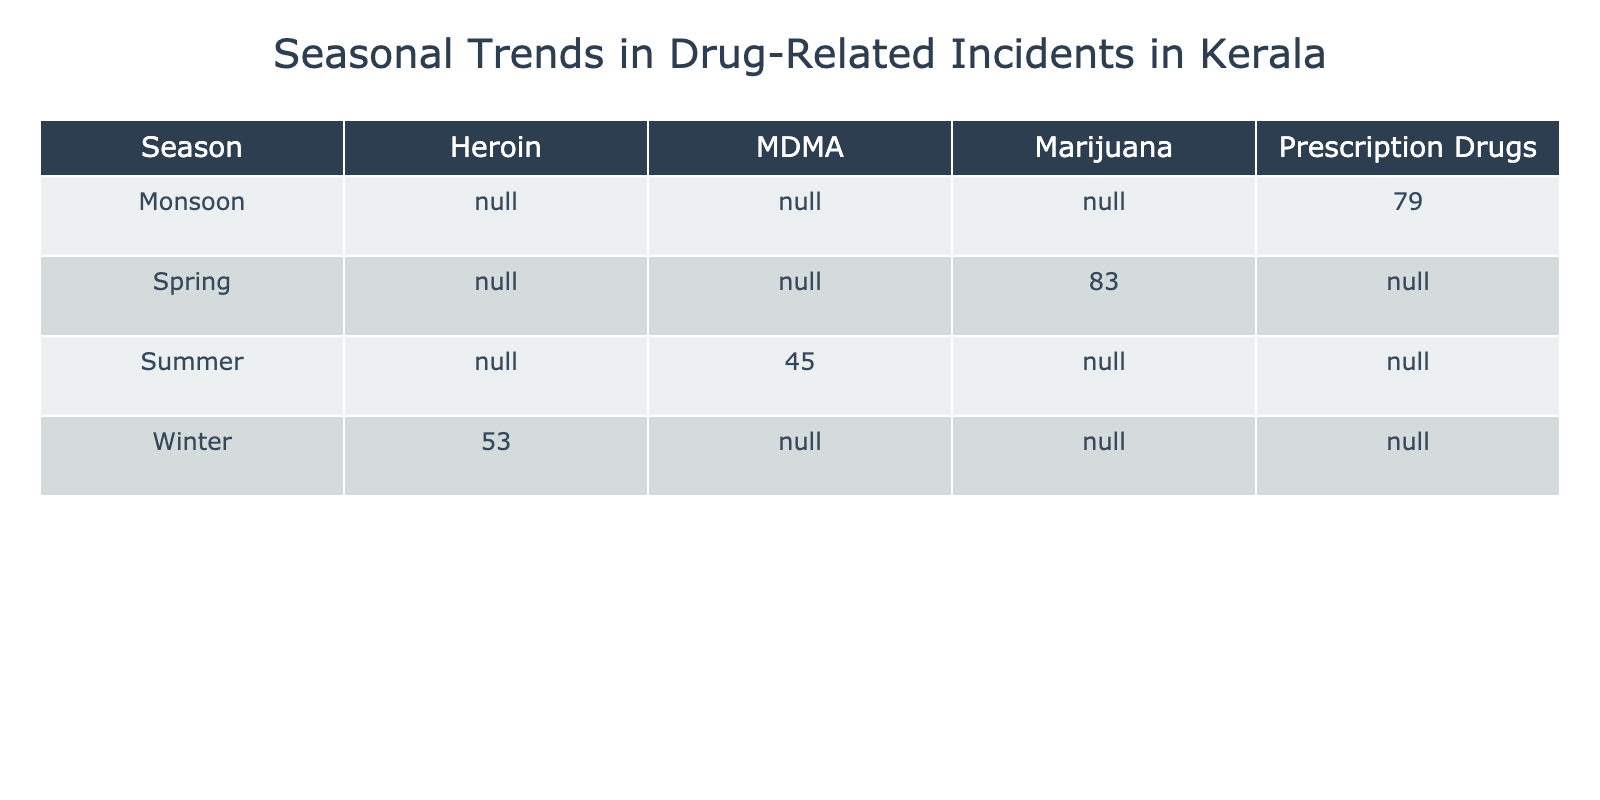What type of drug had the highest number of incidents reported during Spring? In the Spring season, there are three records for the type of drug being Marijuana with reported incidents: March (25), April (30), and May (28). The highest among these is 30 in April.
Answer: Marijuana How many incidents of Prescription Drugs were reported in total? The total incidents reported for Prescription Drugs in the Monsoon season are: September (22), October (30), and November (27). Adding these gives us 22 + 30 + 27 = 79.
Answer: 79 Did the total number of incidents reported for Summer exceed those reported in Winter? For Summer season, we have: June (12), July (15), August (18), totaling 12 + 15 + 18 = 45. In Winter: December (15), January (20), February (18) totals 15 + 20 + 18 = 53. Since 45 is less than 53, it is true that Summer incidents did not exceed Winter.
Answer: No What is the average number of incidents reported for MDMA during the Summer? For MDMA incidents, we have count for: June (12), July (15), and August (18). To find the average, sum these values (12 + 15 + 18 = 45) and divide by the number of months (3), which yields an average of 45/3 = 15.
Answer: 15 Which season had the least total incidents reported across all drug types? We need to compare total incidents reported by each season: Winter: 15 + 20 + 18 = 53, Spring: 25 + 30 + 28 = 83, Summer: 12 + 15 + 18 = 45, Monsoon: 22 + 30 + 27 = 79. The least total is during Summer with 45.
Answer: Summer How many more incidents of Heroin were reported in January compared to February? January reports 20 incidents of Heroin, while February reports 18 incidents. The difference is 20 - 18 = 2, which indicates there were 2 more incidents in January than in February.
Answer: 2 Is the total number of incidents in Monsoon greater than the total in Spring? Total incidents for Monsoon are: September (22), October (30), November (27), totaling 22 + 30 + 27 = 79. For Spring: March (25), April (30), May (28), totaling 25 + 30 + 28 = 83. As 79 is less than 83, Monsoon does not exceed Spring.
Answer: No Which drug type had the highest report in a single month? By checking each month’s incident reports, we have: Heroin (January 20), Marijuana (April 30), MDMA (August 18), Prescription Drugs (October 30). The highest reported incident in a single month is 30 for both Marijuana and Prescription Drugs.
Answer: 30 